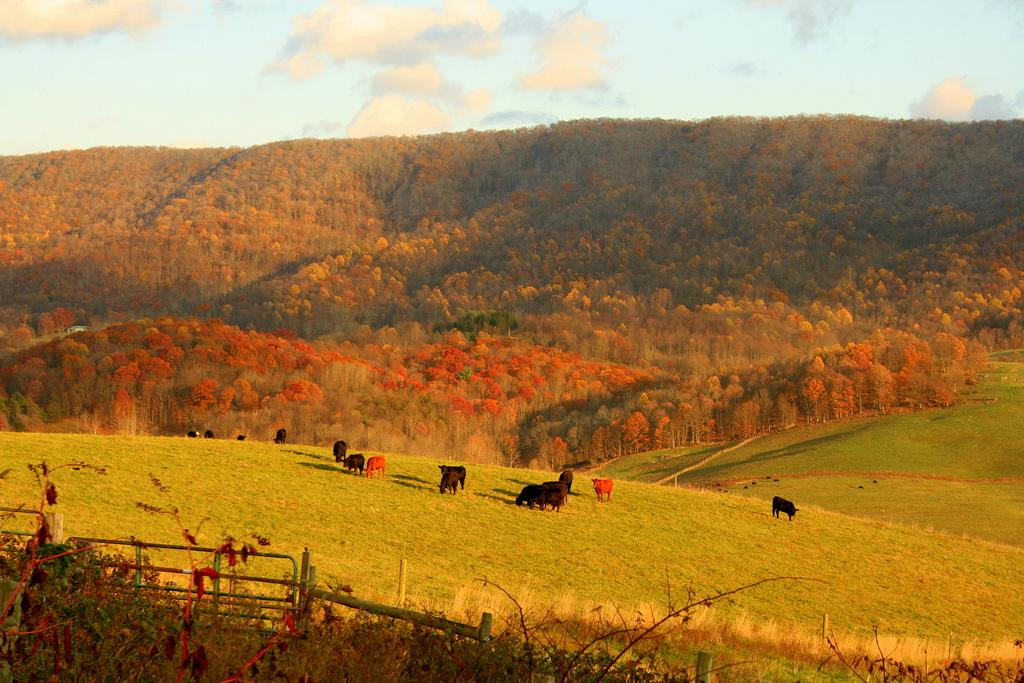What type of structure can be seen in the image? There is a fence in the image. What is located on the ground in the image? There is a group of animals on the ground. What can be seen in the background of the image? There are trees and the sky visible in the background of the image. What is the condition of the sky in the image? Clouds are present in the sky in the background of the image. What type of scissors can be seen in the image? There are no scissors present in the image. Is there a cat visible in the image? There is no cat present in the image. 